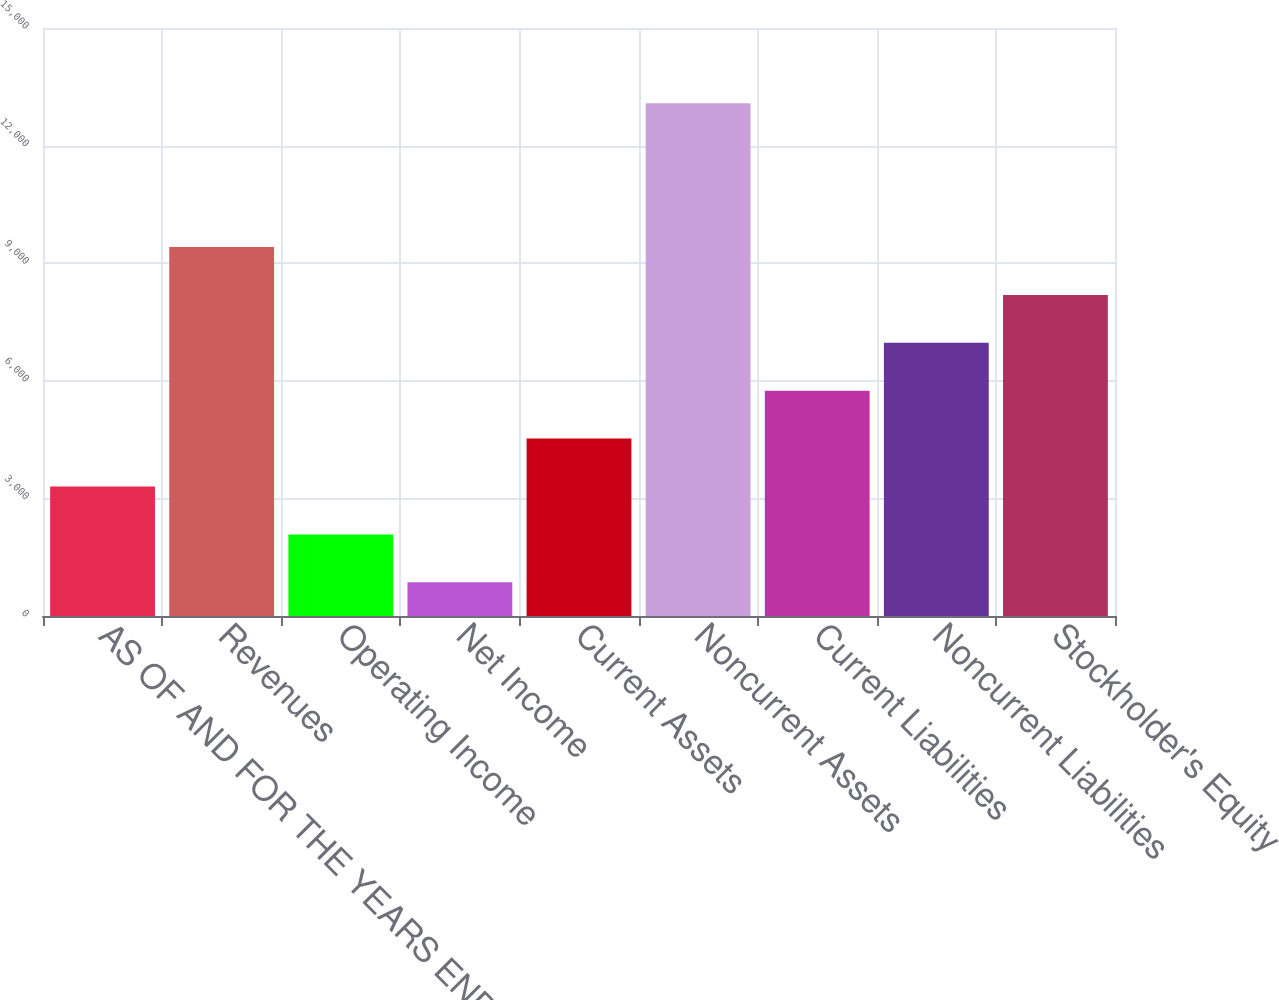Convert chart to OTSL. <chart><loc_0><loc_0><loc_500><loc_500><bar_chart><fcel>AS OF AND FOR THE YEARS ENDED<fcel>Revenues<fcel>Operating Income<fcel>Net Income<fcel>Current Assets<fcel>Noncurrent Assets<fcel>Current Liabilities<fcel>Noncurrent Liabilities<fcel>Stockholder's Equity<nl><fcel>3303.2<fcel>9413.7<fcel>2081.1<fcel>859<fcel>4525.3<fcel>13080<fcel>5747.4<fcel>6969.5<fcel>8191.6<nl></chart> 